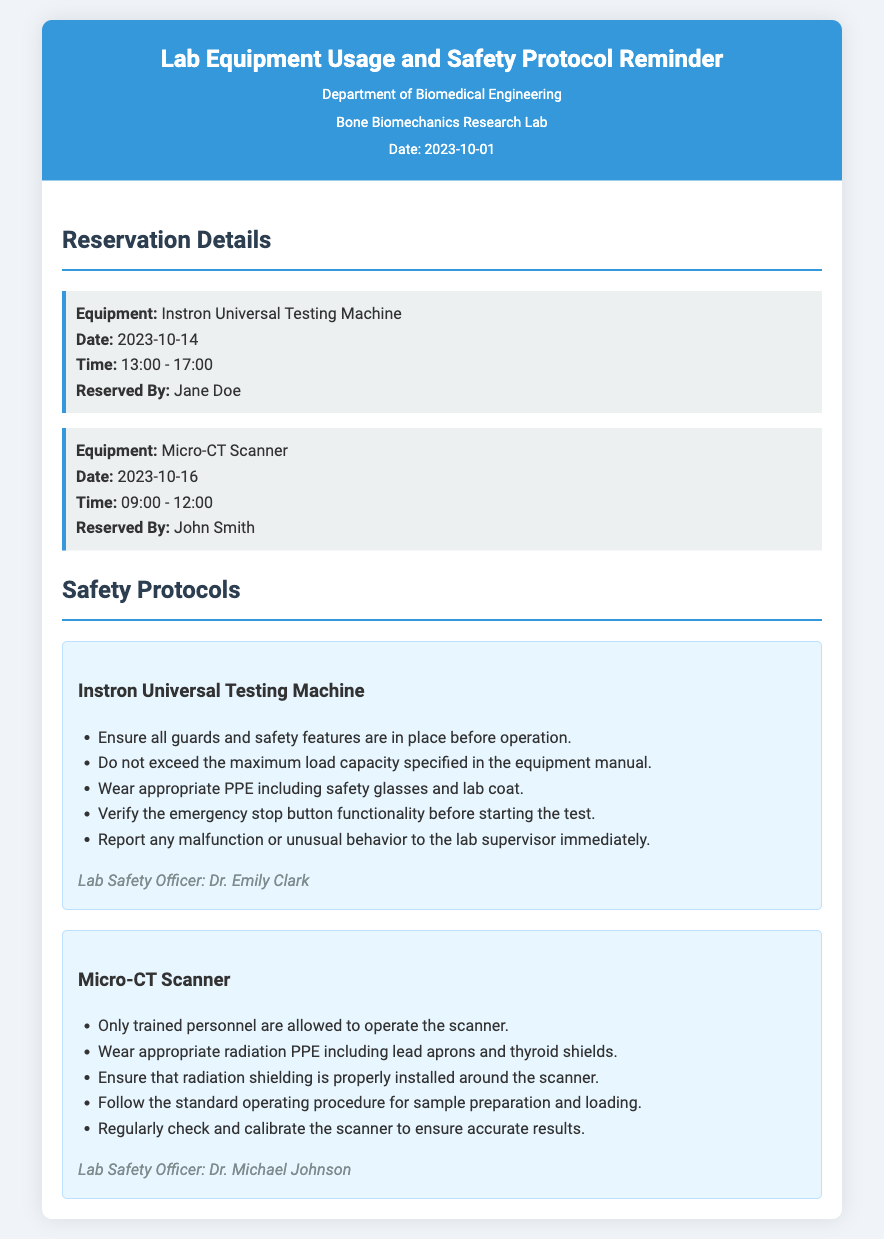What is the date of the reservation for the Instron Universal Testing Machine? The date for the Instron Universal Testing Machine reservation is listed clearly in the document as 2023-10-14.
Answer: 2023-10-14 Who reserved the Micro-CT Scanner? The document mentions that the Micro-CT Scanner was reserved by John Smith.
Answer: John Smith What time is the reservation for the Instron Universal Testing Machine? The time for the Instron Universal Testing Machine reservation is indicated in the document as 13:00 - 17:00.
Answer: 13:00 - 17:00 What should personnel wear when operating the Micro-CT Scanner? The safety protocols for the Micro-CT Scanner specify that appropriate radiation PPE including lead aprons and thyroid shields should be worn.
Answer: lead aprons and thyroid shields Who is responsible for safety protocols regarding the Instron Universal Testing Machine? The document lists Dr. Emily Clark as the Lab Safety Officer responsible for the Instron Universal Testing Machine.
Answer: Dr. Emily Clark What is a safety requirement for operating the Instron Universal Testing Machine? One of the safety requirements specifies not to exceed the maximum load capacity specified in the equipment manual.
Answer: maximum load capacity How many pieces of equipment are mentioned in the document? The document details two pieces of equipment: the Instron Universal Testing Machine and the Micro-CT Scanner.
Answer: two Which lab officer is responsible for the Micro-CT Scanner safety protocols? According to the document, Dr. Michael Johnson is the Lab Safety Officer responsible for the Micro-CT Scanner.
Answer: Dr. Michael Johnson What are the dates for the equipment reservations? The reservations are for 2023-10-14 for the Instron Universal Testing Machine and 2023-10-16 for the Micro-CT Scanner.
Answer: 2023-10-14 and 2023-10-16 